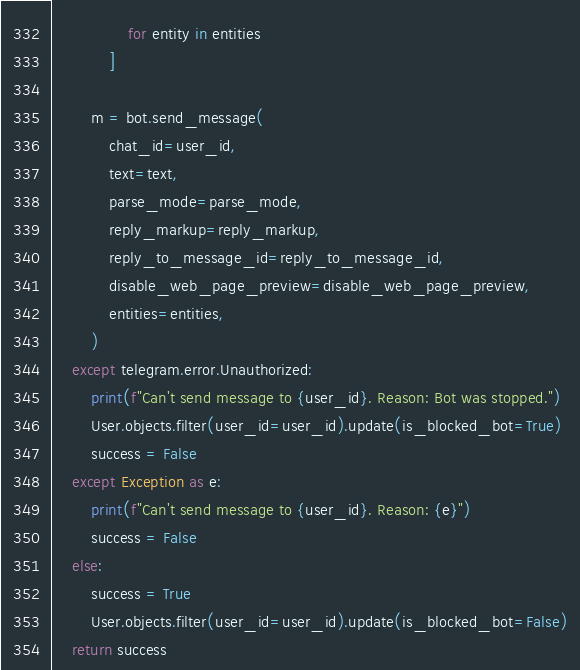<code> <loc_0><loc_0><loc_500><loc_500><_Python_>                for entity in entities
            ]

        m = bot.send_message(
            chat_id=user_id,
            text=text,
            parse_mode=parse_mode,
            reply_markup=reply_markup,
            reply_to_message_id=reply_to_message_id,
            disable_web_page_preview=disable_web_page_preview,
            entities=entities,
        )
    except telegram.error.Unauthorized:
        print(f"Can't send message to {user_id}. Reason: Bot was stopped.")
        User.objects.filter(user_id=user_id).update(is_blocked_bot=True)
        success = False
    except Exception as e:
        print(f"Can't send message to {user_id}. Reason: {e}")
        success = False
    else:
        success = True
        User.objects.filter(user_id=user_id).update(is_blocked_bot=False)
    return success
</code> 